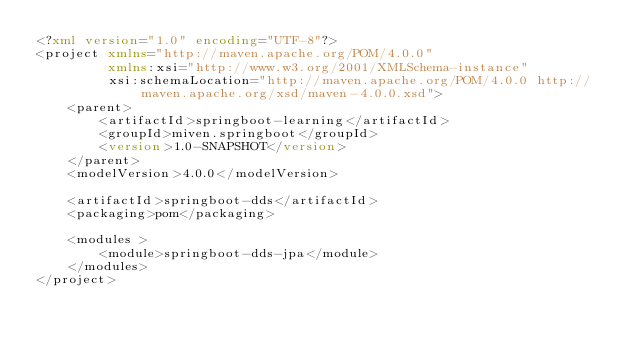Convert code to text. <code><loc_0><loc_0><loc_500><loc_500><_XML_><?xml version="1.0" encoding="UTF-8"?>
<project xmlns="http://maven.apache.org/POM/4.0.0"
         xmlns:xsi="http://www.w3.org/2001/XMLSchema-instance"
         xsi:schemaLocation="http://maven.apache.org/POM/4.0.0 http://maven.apache.org/xsd/maven-4.0.0.xsd">
    <parent>
        <artifactId>springboot-learning</artifactId>
        <groupId>miven.springboot</groupId>
        <version>1.0-SNAPSHOT</version>
    </parent>
    <modelVersion>4.0.0</modelVersion>

    <artifactId>springboot-dds</artifactId>
    <packaging>pom</packaging>

    <modules >
        <module>springboot-dds-jpa</module>
    </modules>
</project></code> 